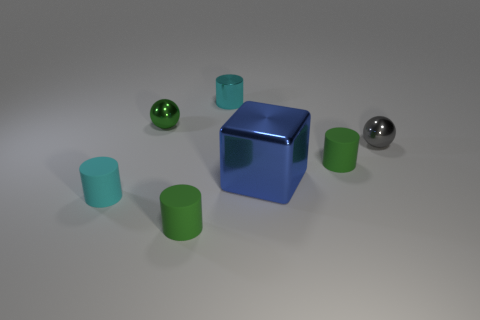What number of other objects are the same material as the blue thing?
Keep it short and to the point. 3. There is a small green matte object behind the green cylinder that is in front of the metallic thing in front of the gray thing; what shape is it?
Offer a terse response. Cylinder. Is the number of tiny objects behind the small cyan metallic cylinder less than the number of green rubber cylinders that are left of the large metallic block?
Provide a short and direct response. Yes. Is there a tiny metallic thing of the same color as the metal cylinder?
Provide a short and direct response. No. Is the cube made of the same material as the cylinder that is behind the gray thing?
Make the answer very short. Yes. There is a green cylinder that is behind the cyan rubber cylinder; is there a small green cylinder that is behind it?
Keep it short and to the point. No. There is a small thing that is behind the gray metal object and to the left of the tiny cyan metal cylinder; what color is it?
Offer a terse response. Green. How big is the cube?
Your answer should be very brief. Large. How many blocks have the same size as the cyan rubber cylinder?
Offer a terse response. 0. Is the blue thing that is on the right side of the cyan rubber cylinder made of the same material as the sphere to the left of the tiny gray object?
Make the answer very short. Yes. 